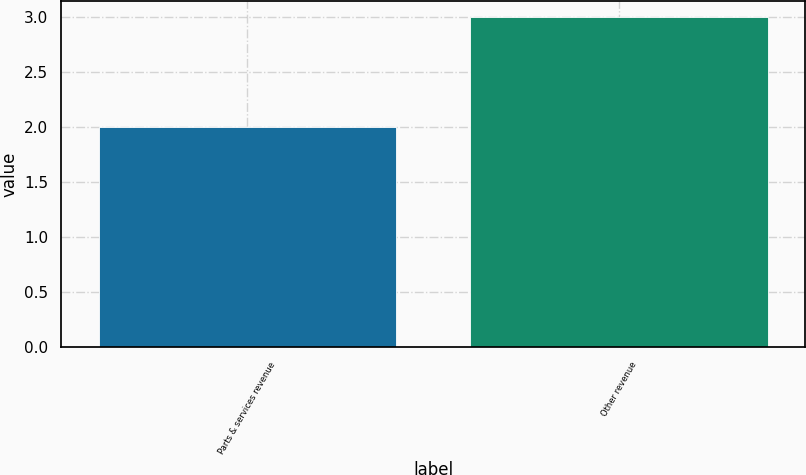Convert chart. <chart><loc_0><loc_0><loc_500><loc_500><bar_chart><fcel>Parts & services revenue<fcel>Other revenue<nl><fcel>2<fcel>3<nl></chart> 